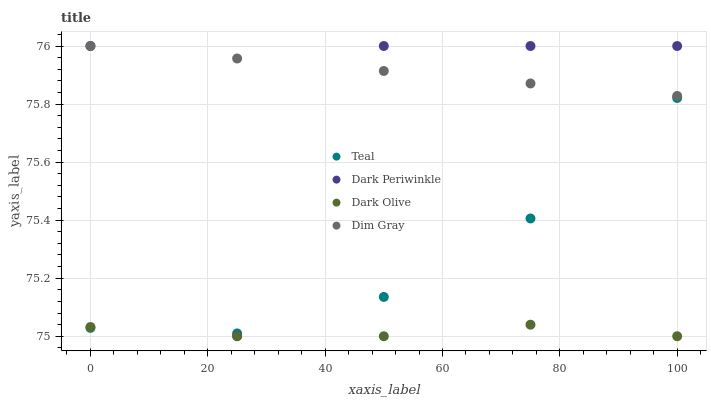Does Dark Olive have the minimum area under the curve?
Answer yes or no. Yes. Does Dim Gray have the maximum area under the curve?
Answer yes or no. Yes. Does Dark Periwinkle have the minimum area under the curve?
Answer yes or no. No. Does Dark Periwinkle have the maximum area under the curve?
Answer yes or no. No. Is Dim Gray the smoothest?
Answer yes or no. Yes. Is Dark Periwinkle the roughest?
Answer yes or no. Yes. Is Dark Olive the smoothest?
Answer yes or no. No. Is Dark Olive the roughest?
Answer yes or no. No. Does Dark Olive have the lowest value?
Answer yes or no. Yes. Does Dark Periwinkle have the lowest value?
Answer yes or no. No. Does Dark Periwinkle have the highest value?
Answer yes or no. Yes. Does Dark Olive have the highest value?
Answer yes or no. No. Is Teal less than Dim Gray?
Answer yes or no. Yes. Is Dark Periwinkle greater than Dark Olive?
Answer yes or no. Yes. Does Dark Periwinkle intersect Teal?
Answer yes or no. Yes. Is Dark Periwinkle less than Teal?
Answer yes or no. No. Is Dark Periwinkle greater than Teal?
Answer yes or no. No. Does Teal intersect Dim Gray?
Answer yes or no. No. 